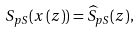Convert formula to latex. <formula><loc_0><loc_0><loc_500><loc_500>S _ { p S } ( x \left ( z \right ) ) = \widehat { S } _ { p S } ( z ) ,</formula> 